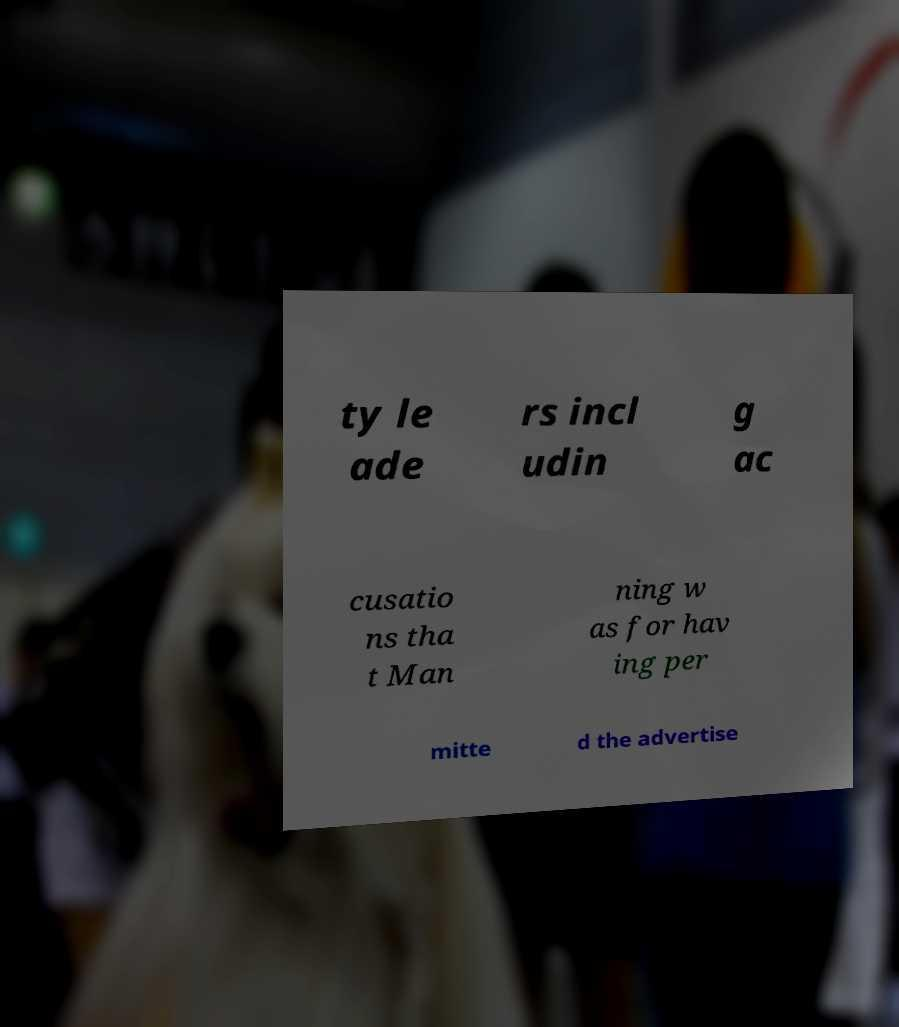Can you read and provide the text displayed in the image?This photo seems to have some interesting text. Can you extract and type it out for me? ty le ade rs incl udin g ac cusatio ns tha t Man ning w as for hav ing per mitte d the advertise 